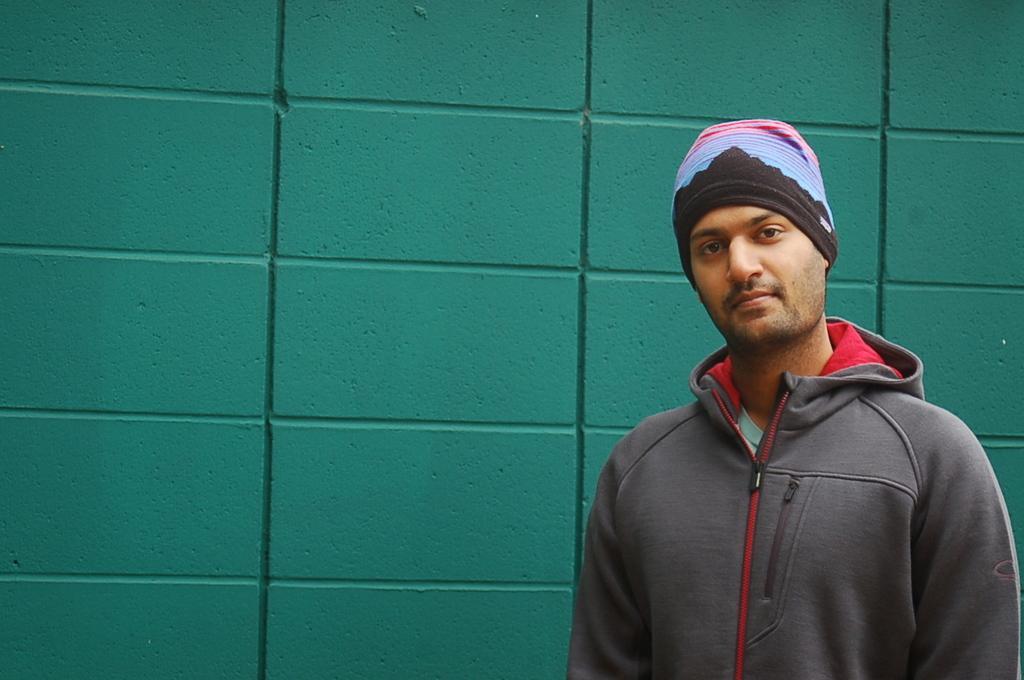Please provide a concise description of this image. In the bottom right corner of the image a man is standing. Behind him there is a wall. 